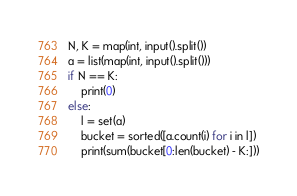Convert code to text. <code><loc_0><loc_0><loc_500><loc_500><_Python_>N, K = map(int, input().split())
a = list(map(int, input().split()))
if N == K:
    print(0)
else:
    l = set(a)
    bucket = sorted([a.count(i) for i in l])
    print(sum(bucket[0:len(bucket) - K:]))</code> 